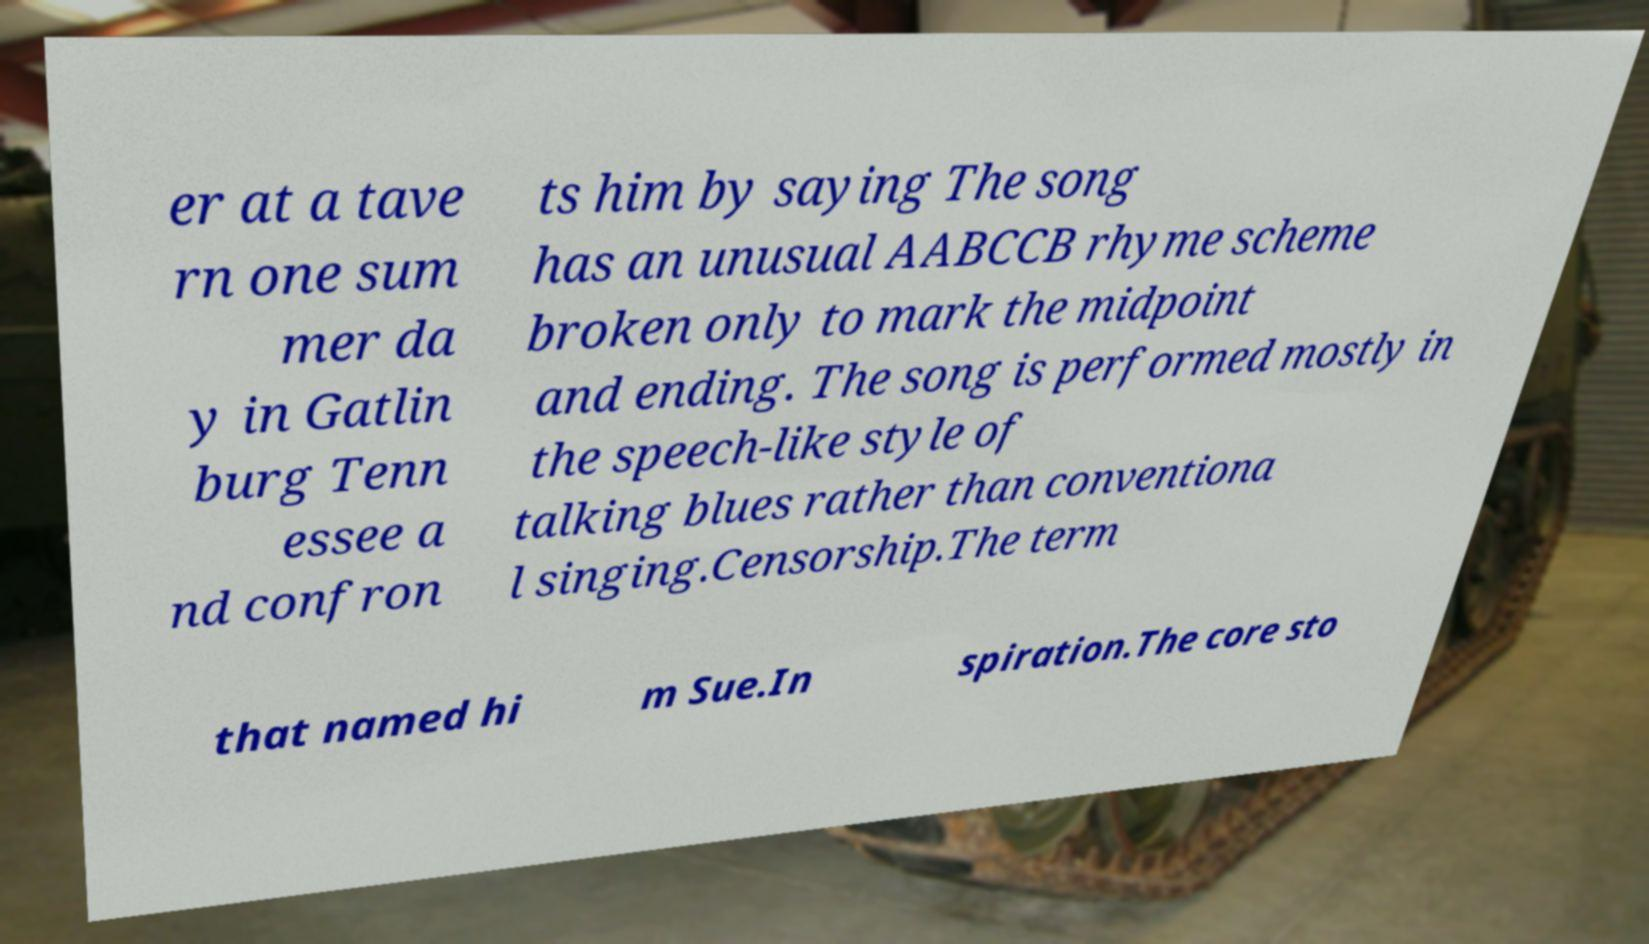What messages or text are displayed in this image? I need them in a readable, typed format. er at a tave rn one sum mer da y in Gatlin burg Tenn essee a nd confron ts him by saying The song has an unusual AABCCB rhyme scheme broken only to mark the midpoint and ending. The song is performed mostly in the speech-like style of talking blues rather than conventiona l singing.Censorship.The term that named hi m Sue.In spiration.The core sto 